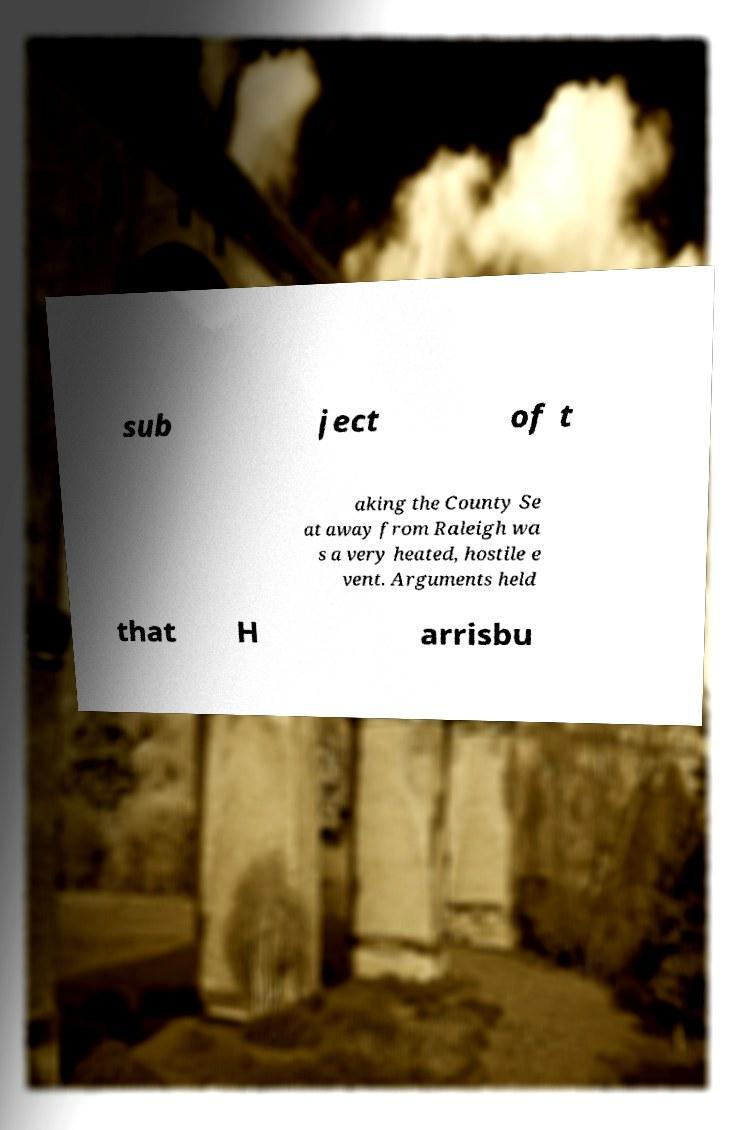For documentation purposes, I need the text within this image transcribed. Could you provide that? sub ject of t aking the County Se at away from Raleigh wa s a very heated, hostile e vent. Arguments held that H arrisbu 